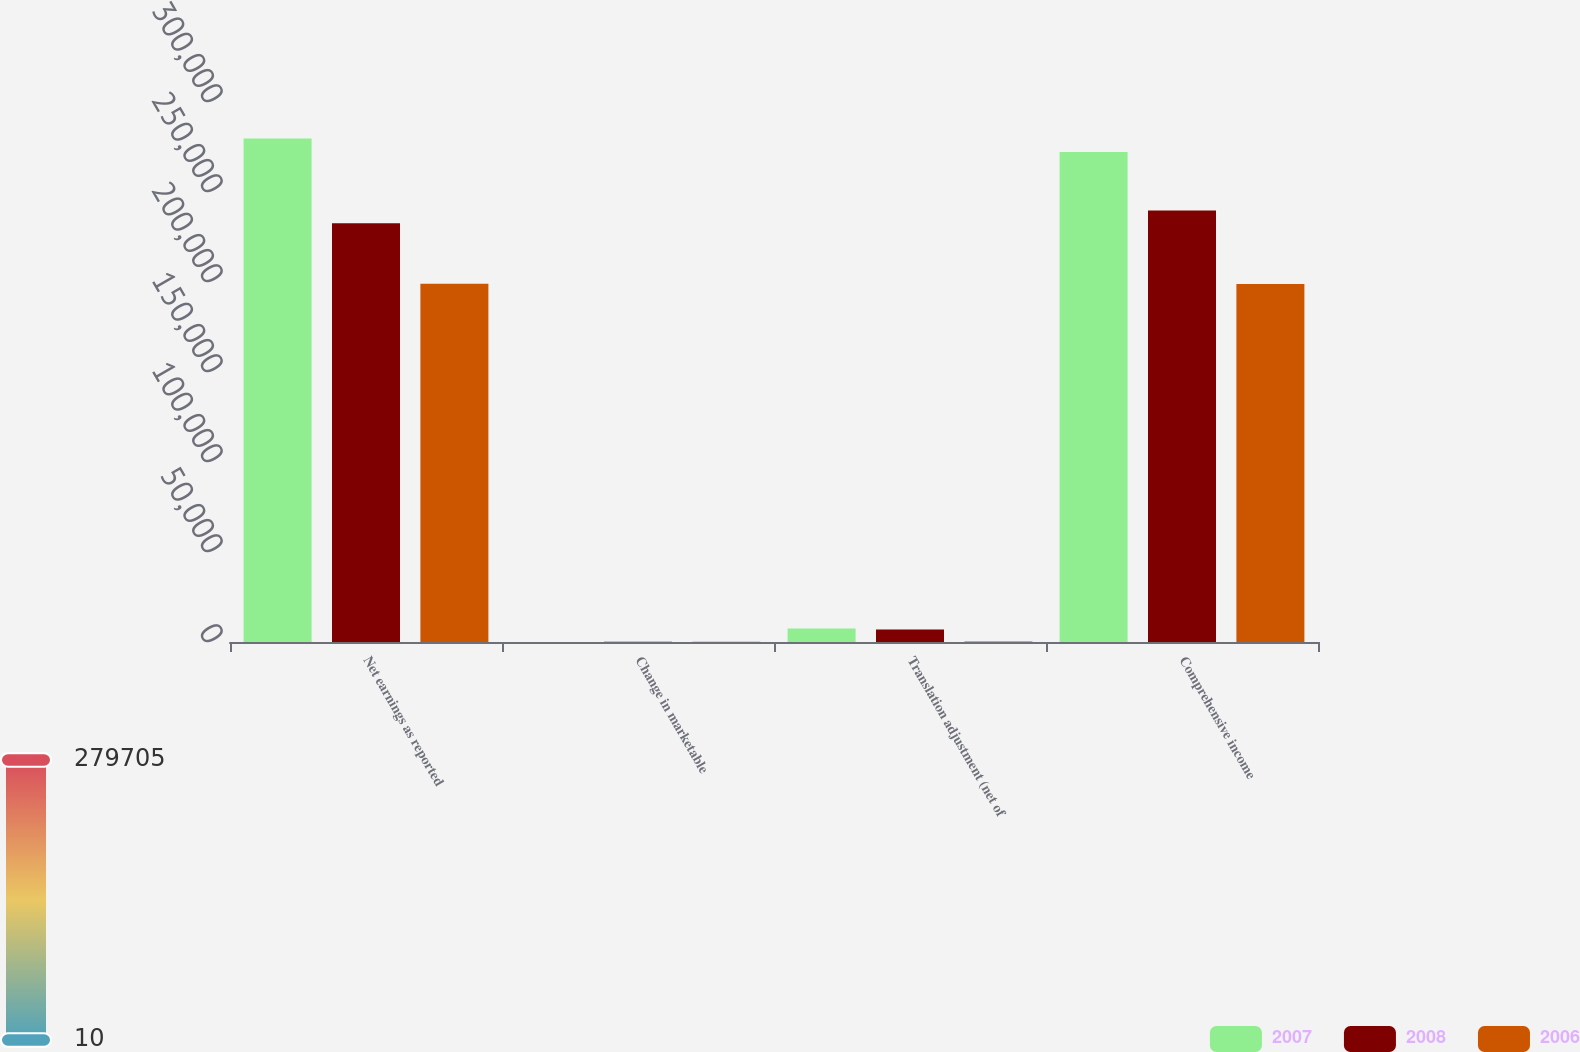Convert chart. <chart><loc_0><loc_0><loc_500><loc_500><stacked_bar_chart><ecel><fcel>Net earnings as reported<fcel>Change in marketable<fcel>Translation adjustment (net of<fcel>Comprehensive income<nl><fcel>2007<fcel>279705<fcel>10<fcel>7432<fcel>272283<nl><fcel>2008<fcel>232622<fcel>102<fcel>6957<fcel>239681<nl><fcel>2006<fcel>199038<fcel>147<fcel>253<fcel>198932<nl></chart> 